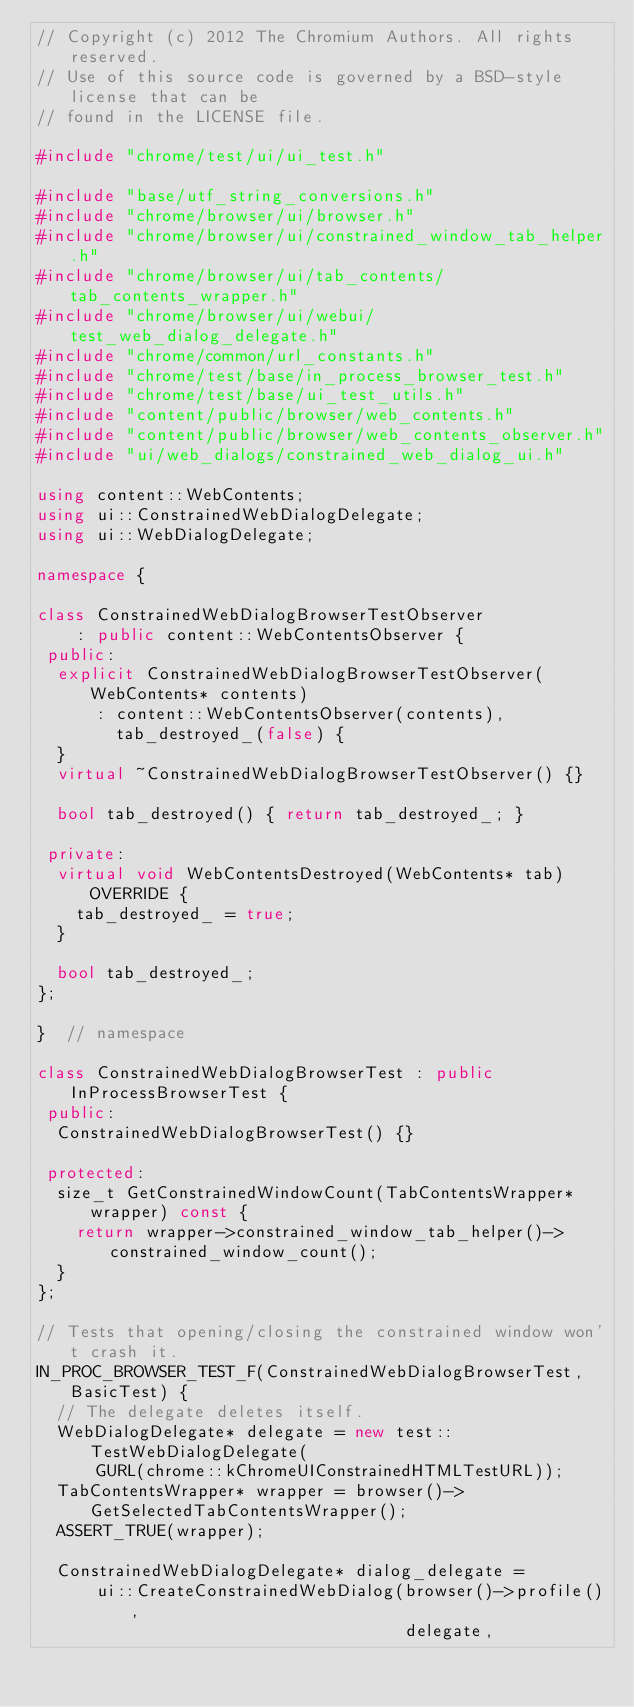<code> <loc_0><loc_0><loc_500><loc_500><_C++_>// Copyright (c) 2012 The Chromium Authors. All rights reserved.
// Use of this source code is governed by a BSD-style license that can be
// found in the LICENSE file.

#include "chrome/test/ui/ui_test.h"

#include "base/utf_string_conversions.h"
#include "chrome/browser/ui/browser.h"
#include "chrome/browser/ui/constrained_window_tab_helper.h"
#include "chrome/browser/ui/tab_contents/tab_contents_wrapper.h"
#include "chrome/browser/ui/webui/test_web_dialog_delegate.h"
#include "chrome/common/url_constants.h"
#include "chrome/test/base/in_process_browser_test.h"
#include "chrome/test/base/ui_test_utils.h"
#include "content/public/browser/web_contents.h"
#include "content/public/browser/web_contents_observer.h"
#include "ui/web_dialogs/constrained_web_dialog_ui.h"

using content::WebContents;
using ui::ConstrainedWebDialogDelegate;
using ui::WebDialogDelegate;

namespace {

class ConstrainedWebDialogBrowserTestObserver
    : public content::WebContentsObserver {
 public:
  explicit ConstrainedWebDialogBrowserTestObserver(WebContents* contents)
      : content::WebContentsObserver(contents),
        tab_destroyed_(false) {
  }
  virtual ~ConstrainedWebDialogBrowserTestObserver() {}

  bool tab_destroyed() { return tab_destroyed_; }

 private:
  virtual void WebContentsDestroyed(WebContents* tab) OVERRIDE {
    tab_destroyed_ = true;
  }

  bool tab_destroyed_;
};

}  // namespace

class ConstrainedWebDialogBrowserTest : public InProcessBrowserTest {
 public:
  ConstrainedWebDialogBrowserTest() {}

 protected:
  size_t GetConstrainedWindowCount(TabContentsWrapper* wrapper) const {
    return wrapper->constrained_window_tab_helper()->constrained_window_count();
  }
};

// Tests that opening/closing the constrained window won't crash it.
IN_PROC_BROWSER_TEST_F(ConstrainedWebDialogBrowserTest, BasicTest) {
  // The delegate deletes itself.
  WebDialogDelegate* delegate = new test::TestWebDialogDelegate(
      GURL(chrome::kChromeUIConstrainedHTMLTestURL));
  TabContentsWrapper* wrapper = browser()->GetSelectedTabContentsWrapper();
  ASSERT_TRUE(wrapper);

  ConstrainedWebDialogDelegate* dialog_delegate =
      ui::CreateConstrainedWebDialog(browser()->profile(),
                                     delegate,</code> 